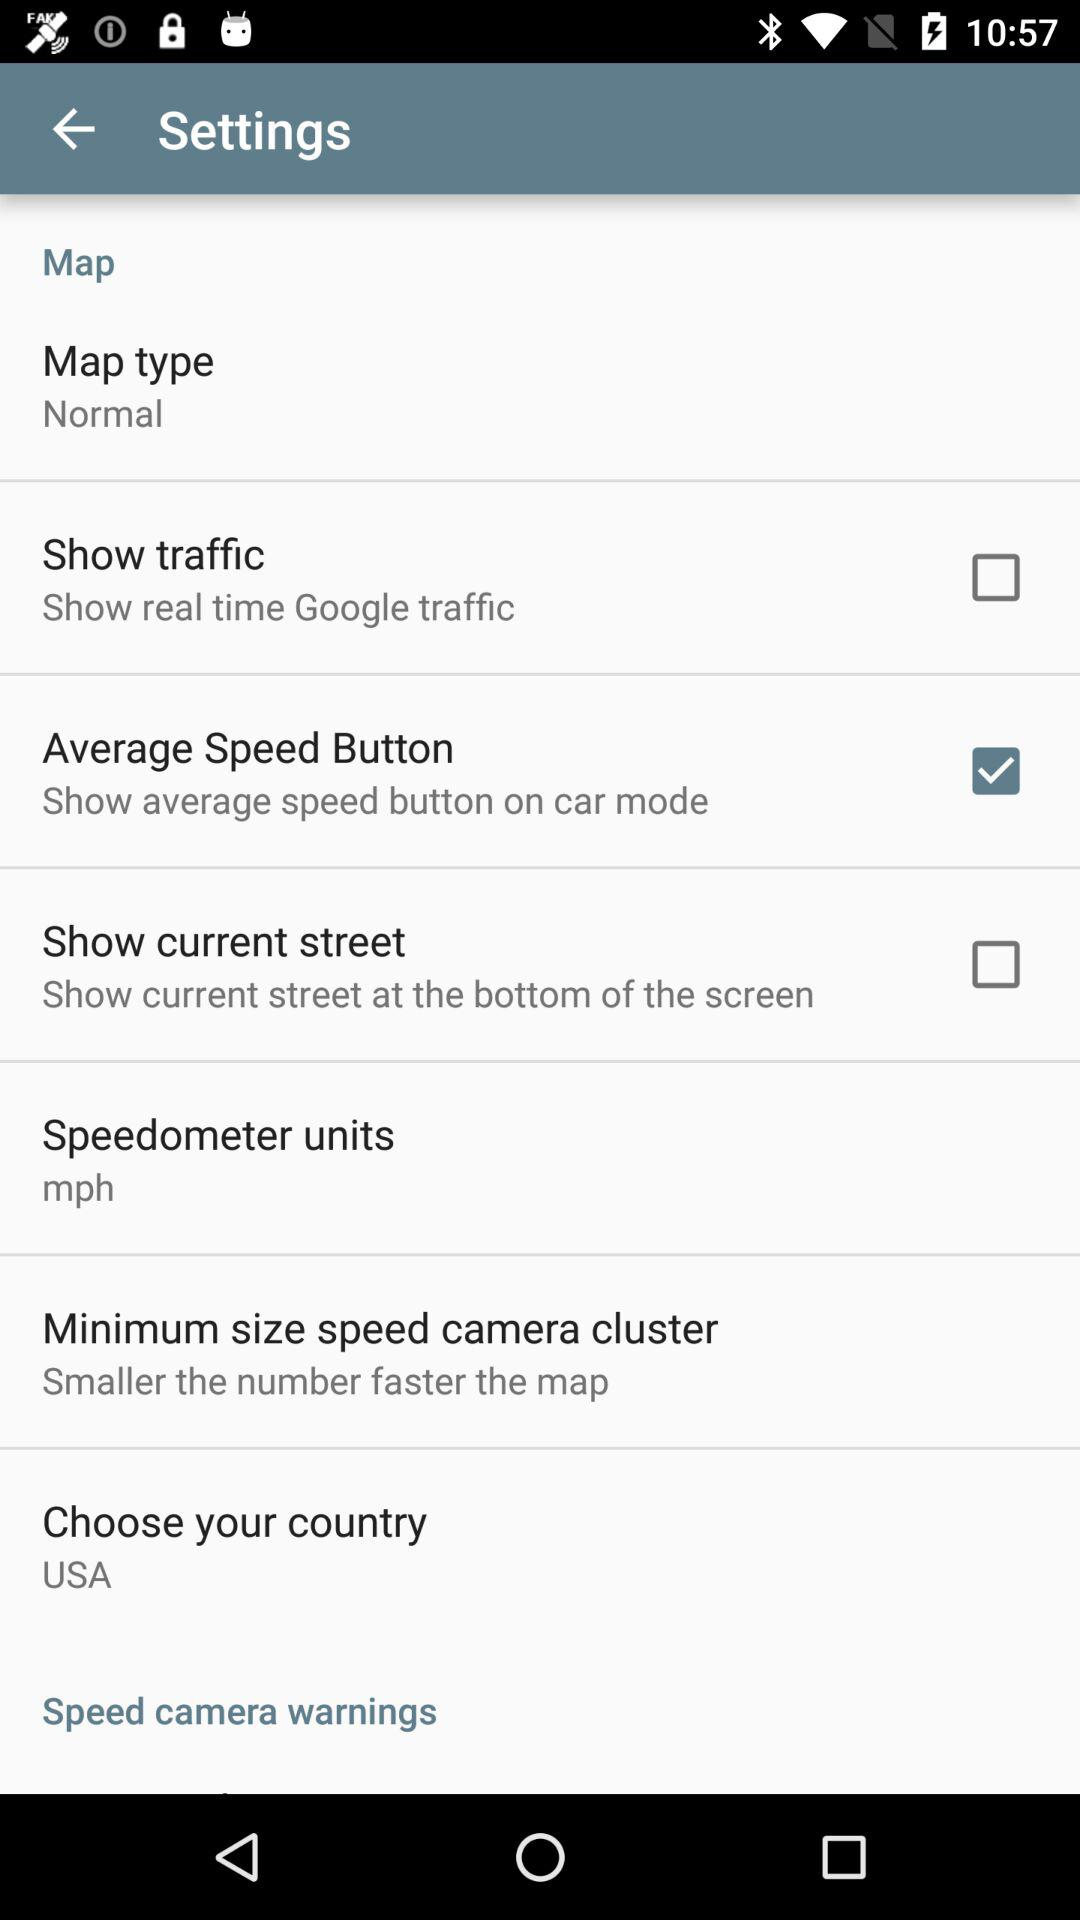What's the unit of the speedometer? The unit of the speedometer is mph. 